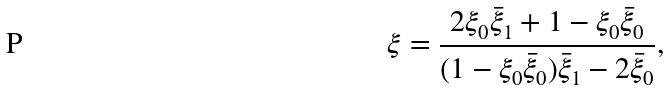<formula> <loc_0><loc_0><loc_500><loc_500>\xi = \frac { 2 \xi _ { 0 } \bar { \xi } _ { 1 } + 1 - \xi _ { 0 } \bar { \xi } _ { 0 } } { ( 1 - \xi _ { 0 } \bar { \xi } _ { 0 } ) \bar { \xi } _ { 1 } - 2 \bar { \xi } _ { 0 } } ,</formula> 